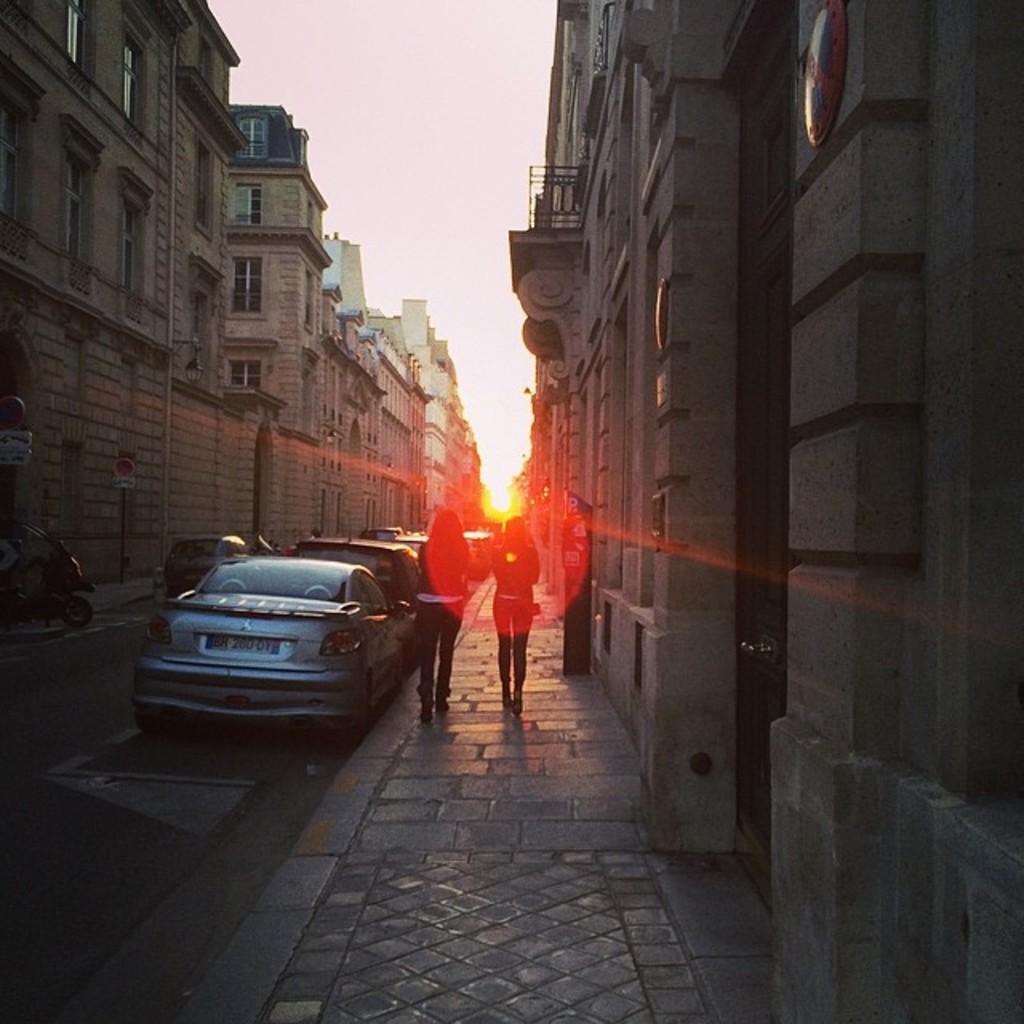Please provide a concise description of this image. In this image I can see two persons walking and I can also see few vehicles on the road. In the background I can see few buildings and the sky is in white color and I can also see the sun. 